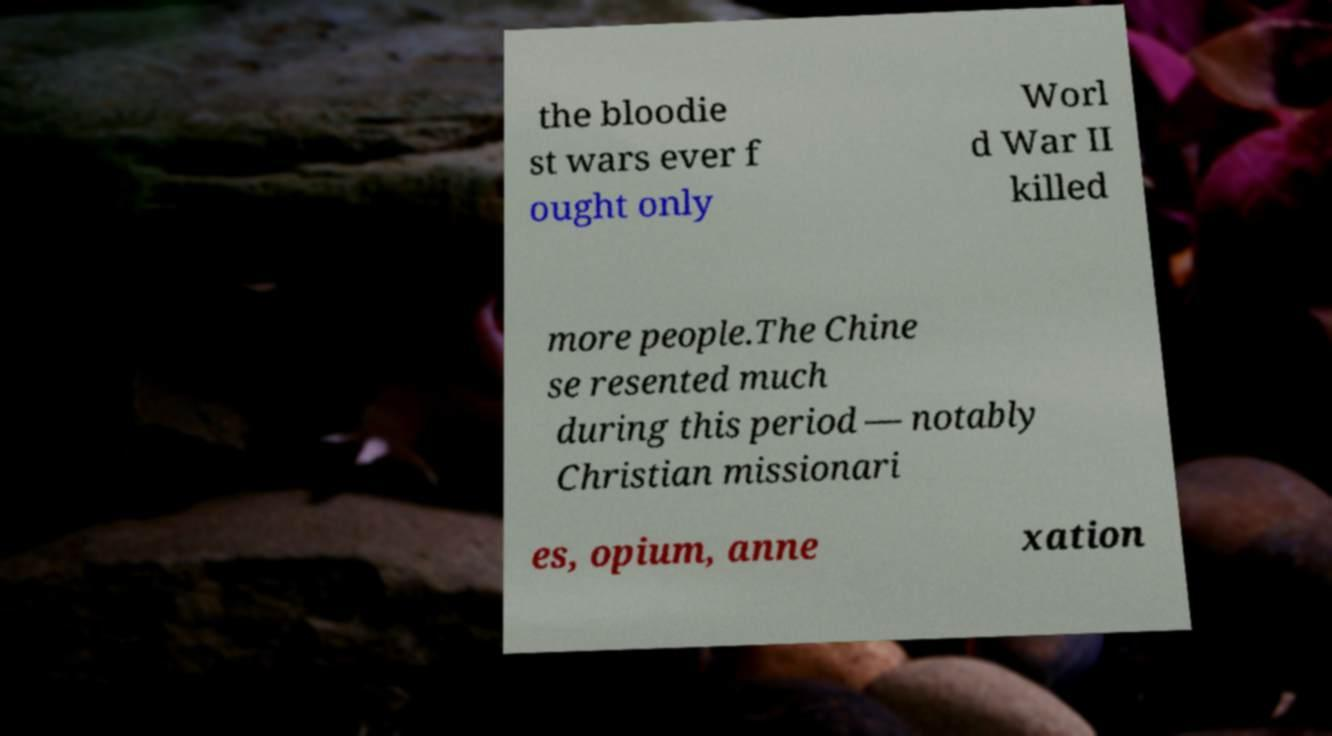Could you extract and type out the text from this image? the bloodie st wars ever f ought only Worl d War II killed more people.The Chine se resented much during this period — notably Christian missionari es, opium, anne xation 